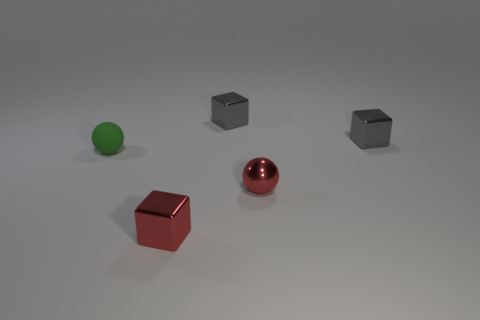Add 3 green matte cubes. How many objects exist? 8 Subtract all balls. How many objects are left? 3 Subtract all small green spheres. Subtract all gray blocks. How many objects are left? 2 Add 5 tiny red shiny things. How many tiny red shiny things are left? 7 Add 2 tiny gray metallic blocks. How many tiny gray metallic blocks exist? 4 Subtract 0 brown cylinders. How many objects are left? 5 